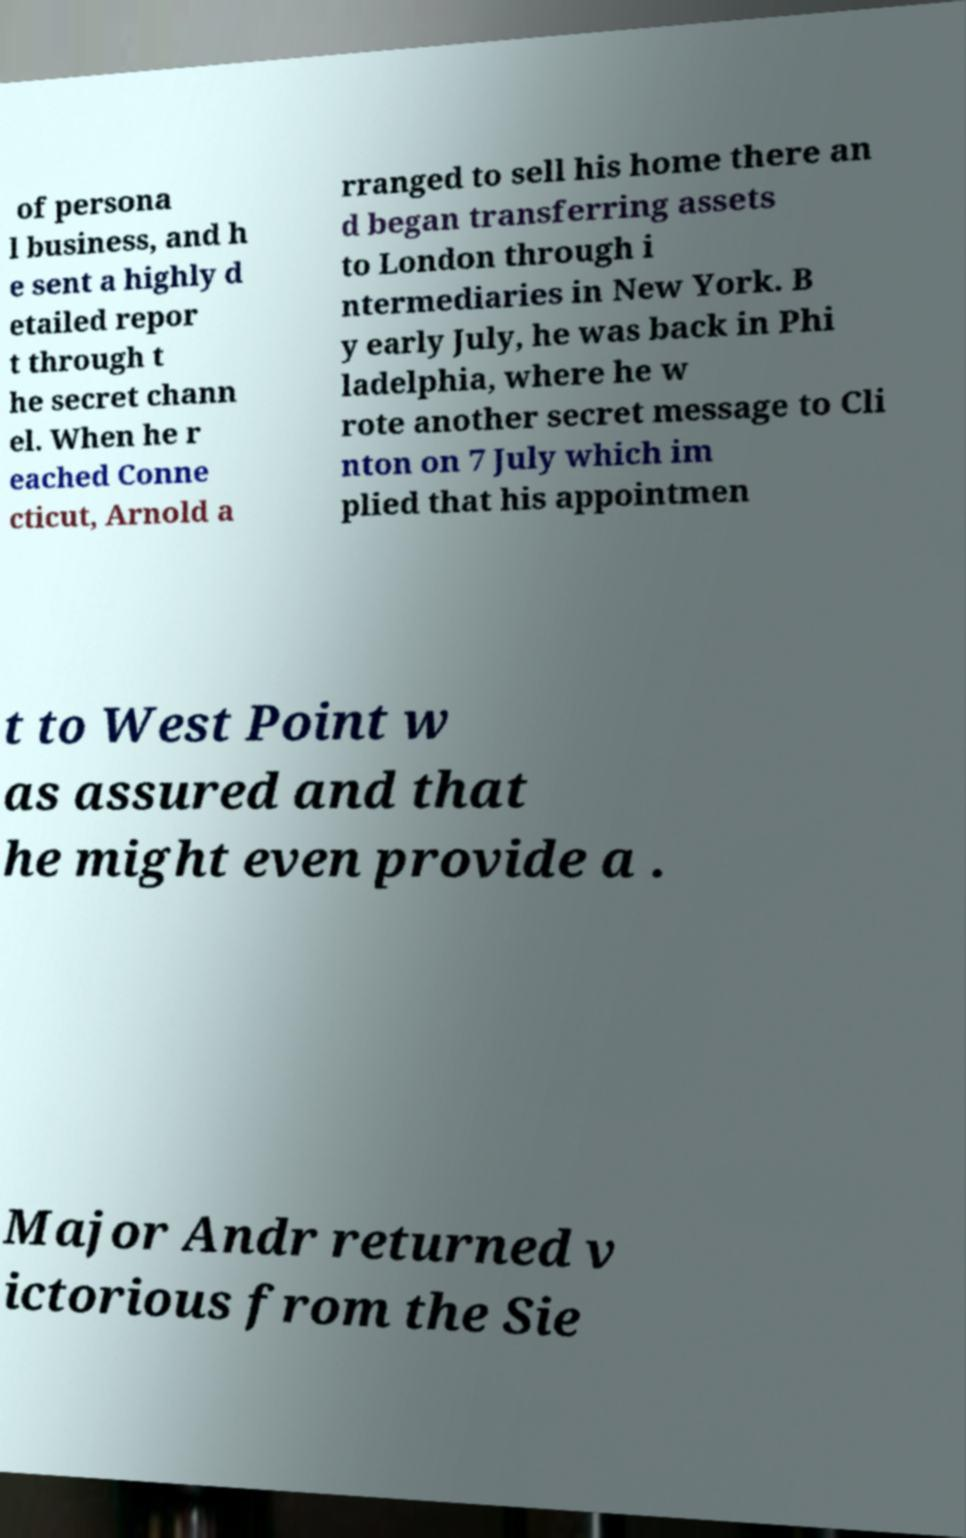Please identify and transcribe the text found in this image. of persona l business, and h e sent a highly d etailed repor t through t he secret chann el. When he r eached Conne cticut, Arnold a rranged to sell his home there an d began transferring assets to London through i ntermediaries in New York. B y early July, he was back in Phi ladelphia, where he w rote another secret message to Cli nton on 7 July which im plied that his appointmen t to West Point w as assured and that he might even provide a . Major Andr returned v ictorious from the Sie 